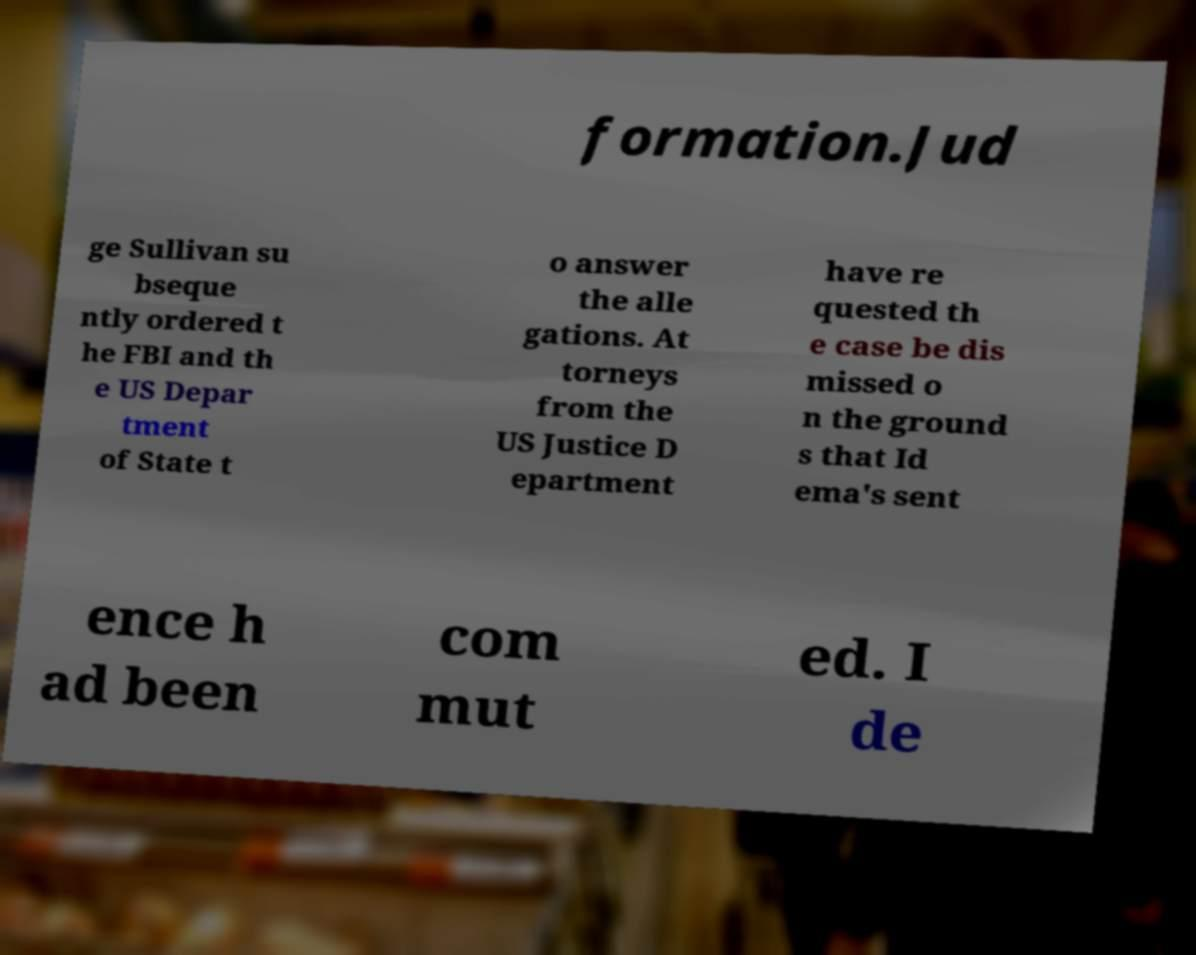What messages or text are displayed in this image? I need them in a readable, typed format. formation.Jud ge Sullivan su bseque ntly ordered t he FBI and th e US Depar tment of State t o answer the alle gations. At torneys from the US Justice D epartment have re quested th e case be dis missed o n the ground s that Id ema's sent ence h ad been com mut ed. I de 